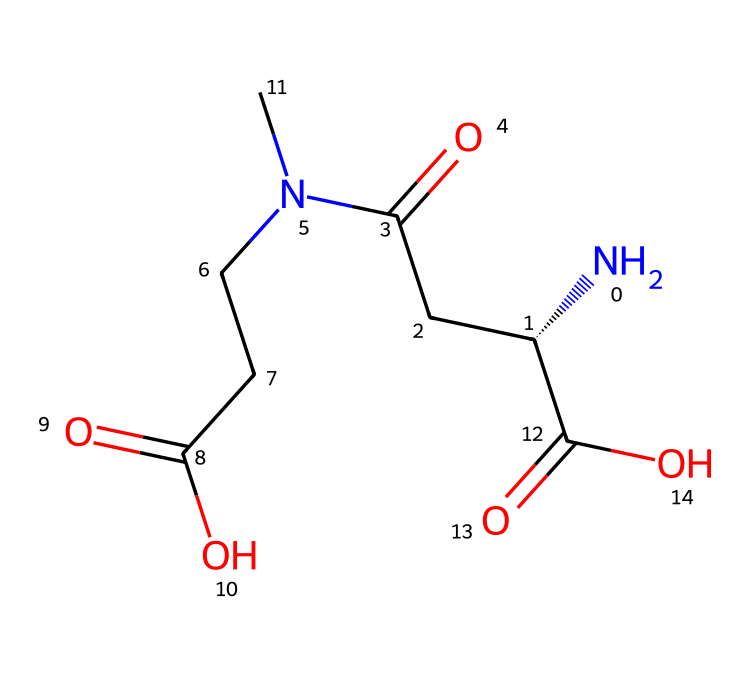How many carbon atoms are in L-theanine? By examining the SMILES representation, we identify the carbon atoms denoted by 'C'. Counting each 'C' in the structure leads us to a total of 7 carbon atoms present.
Answer: 7 What functional groups are present in L-theanine? Analyzing the structure, we can identify carboxylic acid (–COOH) and amine (–NH2) functional groups by the presence of carbonyl (C=O) and nitrogen (N) atoms. This reveals that both a carboxylic acid and an amine group are part of the molecular structure.
Answer: carboxylic acid and amine Is L-theanine a chiral compound? The presence of an asymmetric carbon atom in the structure, indicated by the '@' symbol in the SMILES, suggests that L-theanine has a stereocenter, making it chiral.
Answer: yes What is the molecular weight of L-theanine? To determine the molecular weight, we would sum the atomic weights of all the atoms present in the structure. Based on the visual representation, the weights of carbon, hydrogen, nitrogen, and oxygen atoms after careful calculations yield a total molecular weight of approximately 174 grams per mole.
Answer: 174 Which part of the molecule is responsible for its relaxing effect? The presence of the amine functional group (specifically its nitrogen atom) indicates that L-theanine has properties associated with neurotransmission, which contributes to its relaxing effect.
Answer: amine group How many nitrogen atoms are in the structure of L-theanine? From the SMILES representation, we can count the number of nitrogen atoms present, which is identified by the 'N' characters. In this case, there are 2 nitrogen atoms in the structure.
Answer: 2 